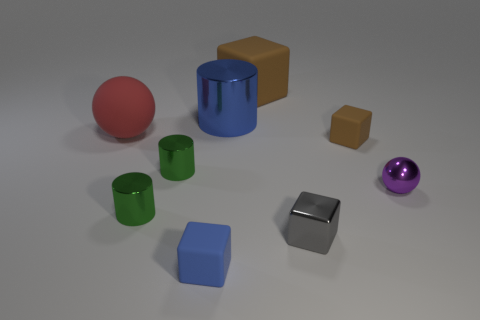Subtract all gray blocks. How many blocks are left? 3 Subtract all tiny gray shiny cubes. How many cubes are left? 3 Add 1 gray matte objects. How many objects exist? 10 Subtract all purple blocks. Subtract all gray balls. How many blocks are left? 4 Subtract all spheres. How many objects are left? 7 Subtract all blue blocks. Subtract all small brown things. How many objects are left? 7 Add 2 blue matte blocks. How many blue matte blocks are left? 3 Add 8 purple metal spheres. How many purple metal spheres exist? 9 Subtract 0 cyan cylinders. How many objects are left? 9 